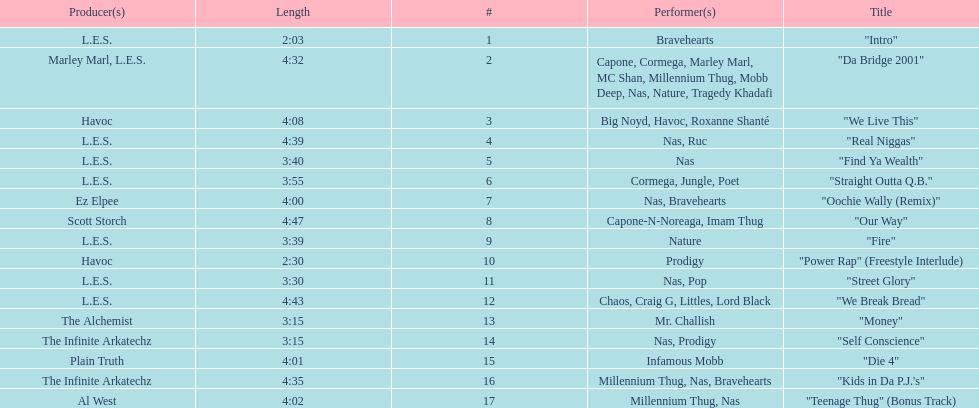How many songs were on the track list? 17. 